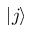<formula> <loc_0><loc_0><loc_500><loc_500>| j \rangle</formula> 